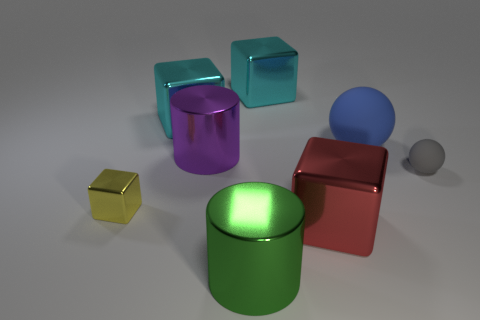What number of other things are the same shape as the gray rubber thing?
Give a very brief answer. 1. There is a big block in front of the small ball that is to the right of the large blue object; what is it made of?
Make the answer very short. Metal. There is a blue rubber ball; are there any metallic cylinders to the right of it?
Offer a very short reply. No. There is a blue matte object; is its size the same as the cube in front of the small yellow shiny block?
Keep it short and to the point. Yes. What is the size of the other shiny object that is the same shape as the green metal object?
Give a very brief answer. Large. Is there anything else that is the same material as the big ball?
Provide a succinct answer. Yes. There is a sphere that is in front of the blue thing; does it have the same size as the cylinder that is behind the small gray rubber object?
Your answer should be very brief. No. What number of small things are gray matte balls or blue things?
Keep it short and to the point. 1. What number of metal cubes are both left of the purple cylinder and right of the yellow shiny block?
Keep it short and to the point. 1. Is the material of the large red cube the same as the small object that is left of the big blue object?
Offer a very short reply. Yes. 